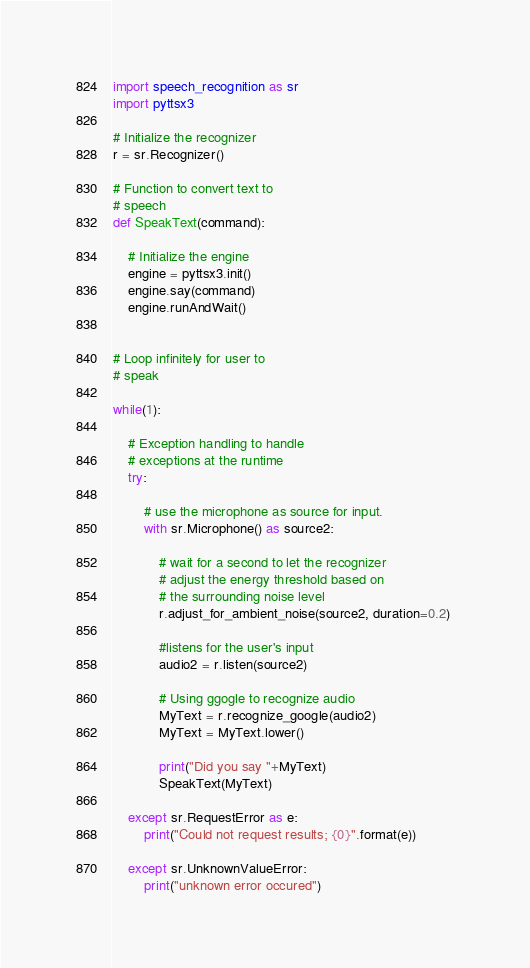Convert code to text. <code><loc_0><loc_0><loc_500><loc_500><_Python_>import speech_recognition as sr 
import pyttsx3  
  
# Initialize the recognizer  
r = sr.Recognizer()  
  
# Function to convert text to 
# speech 
def SpeakText(command): 
      
    # Initialize the engine 
    engine = pyttsx3.init() 
    engine.say(command)  
    engine.runAndWait() 
      
      
# Loop infinitely for user to 
# speak 
  
while(1):     
      
    # Exception handling to handle 
    # exceptions at the runtime 
    try: 
          
        # use the microphone as source for input. 
        with sr.Microphone() as source2: 
              
            # wait for a second to let the recognizer 
            # adjust the energy threshold based on 
            # the surrounding noise level  
            r.adjust_for_ambient_noise(source2, duration=0.2) 
              
            #listens for the user's input  
            audio2 = r.listen(source2) 
              
            # Using ggogle to recognize audio 
            MyText = r.recognize_google(audio2) 
            MyText = MyText.lower() 
  
            print("Did you say "+MyText) 
            SpeakText(MyText) 
              
    except sr.RequestError as e: 
        print("Could not request results; {0}".format(e)) 
          
    except sr.UnknownValueError: 
        print("unknown error occured") </code> 